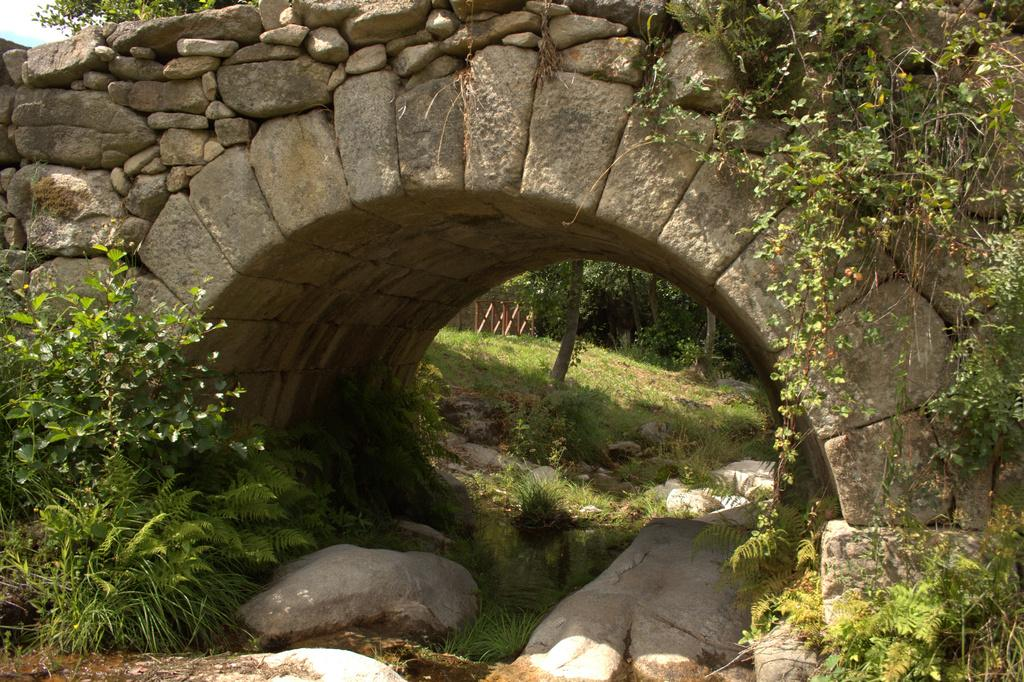What type of structure is in the image? There is a stone bridge in the image. What can be seen under the bridge? There are stones visible under the bridge. What type of vegetation is present in the image? Plants are present in the image. What is visible in the image besides the bridge and plants? There is water visible in the image. How is the plant interacting with the bridge? A plant is creeping on the bridge. What type of celery is growing on the wrist of the person in the image? There is no person or celery present in the image. 